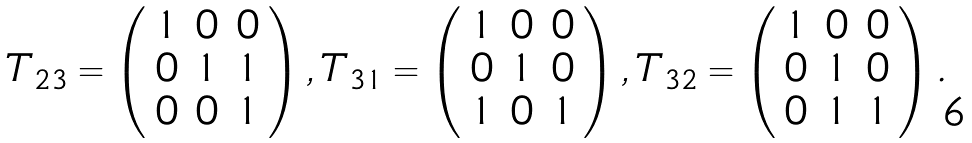<formula> <loc_0><loc_0><loc_500><loc_500>T _ { 2 3 } = \left ( \begin{array} { r r r } 1 & 0 & 0 \\ 0 & 1 & 1 \\ 0 & 0 & 1 \end{array} \right ) , T _ { 3 1 } = \left ( \begin{array} { r r r } 1 & 0 & 0 \\ 0 & 1 & 0 \\ 1 & 0 & 1 \end{array} \right ) , T _ { 3 2 } = \left ( \begin{array} { r r r } 1 & 0 & 0 \\ 0 & 1 & 0 \\ 0 & 1 & 1 \end{array} \right ) .</formula> 